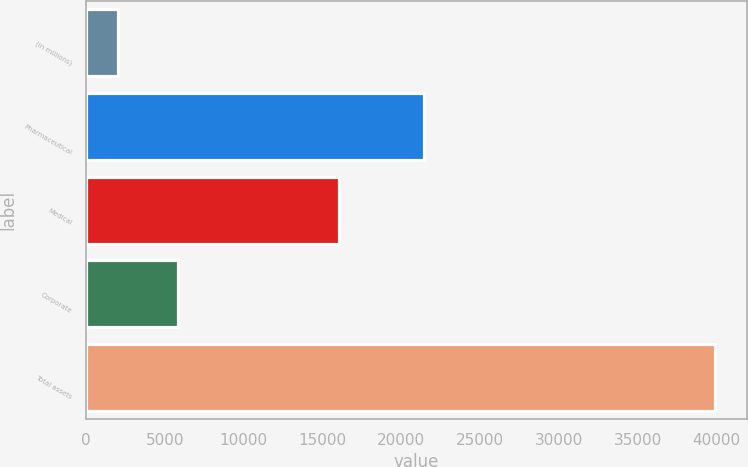Convert chart to OTSL. <chart><loc_0><loc_0><loc_500><loc_500><bar_chart><fcel>(in millions)<fcel>Pharmaceutical<fcel>Medical<fcel>Corporate<fcel>Total assets<nl><fcel>2018<fcel>21421<fcel>16066<fcel>5811.3<fcel>39951<nl></chart> 